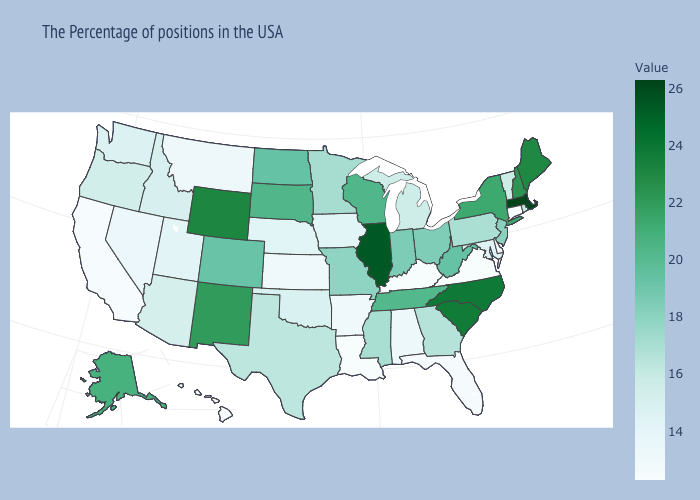Which states have the lowest value in the USA?
Answer briefly. Connecticut, Delaware, Virginia, Kentucky, Louisiana, Hawaii. Does Texas have a higher value than Hawaii?
Keep it brief. Yes. Does the map have missing data?
Short answer required. No. Is the legend a continuous bar?
Short answer required. Yes. Which states hav the highest value in the MidWest?
Answer briefly. Illinois. 